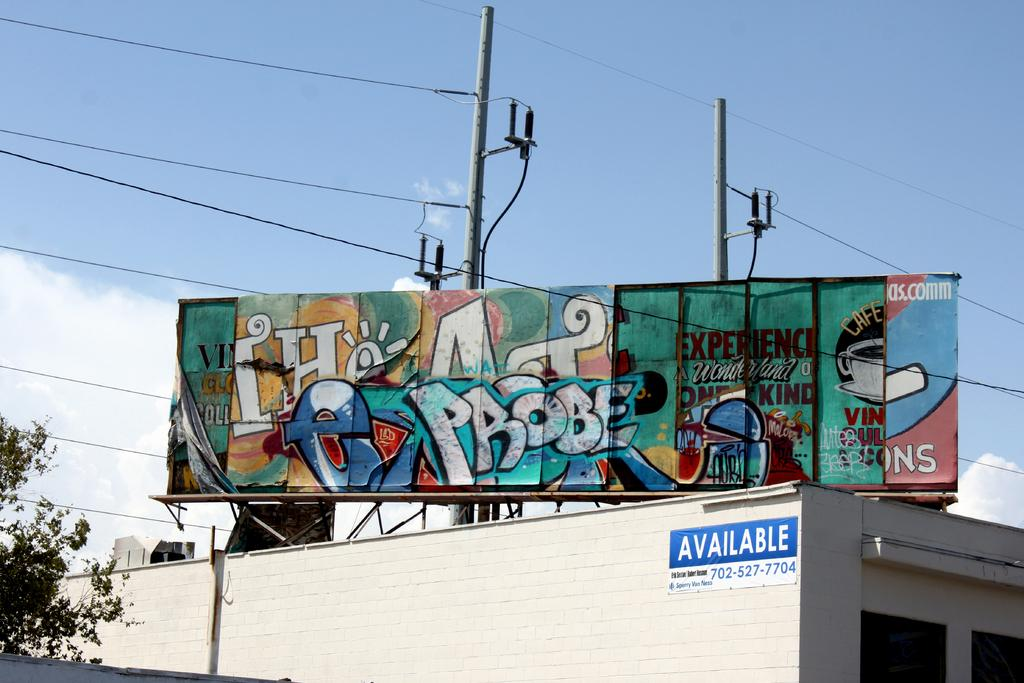<image>
Write a terse but informative summary of the picture. A billboard on top of a building that is Available, has been grafittied with the word Probe. 